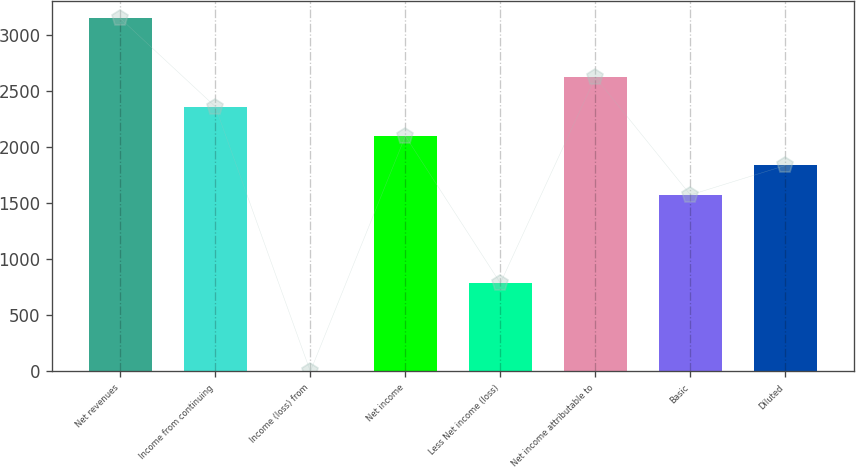<chart> <loc_0><loc_0><loc_500><loc_500><bar_chart><fcel>Net revenues<fcel>Income from continuing<fcel>Income (loss) from<fcel>Net income<fcel>Less Net income (loss)<fcel>Net income attributable to<fcel>Basic<fcel>Diluted<nl><fcel>3147.62<fcel>2360.72<fcel>0.02<fcel>2098.42<fcel>786.92<fcel>2623.02<fcel>1573.82<fcel>1836.12<nl></chart> 